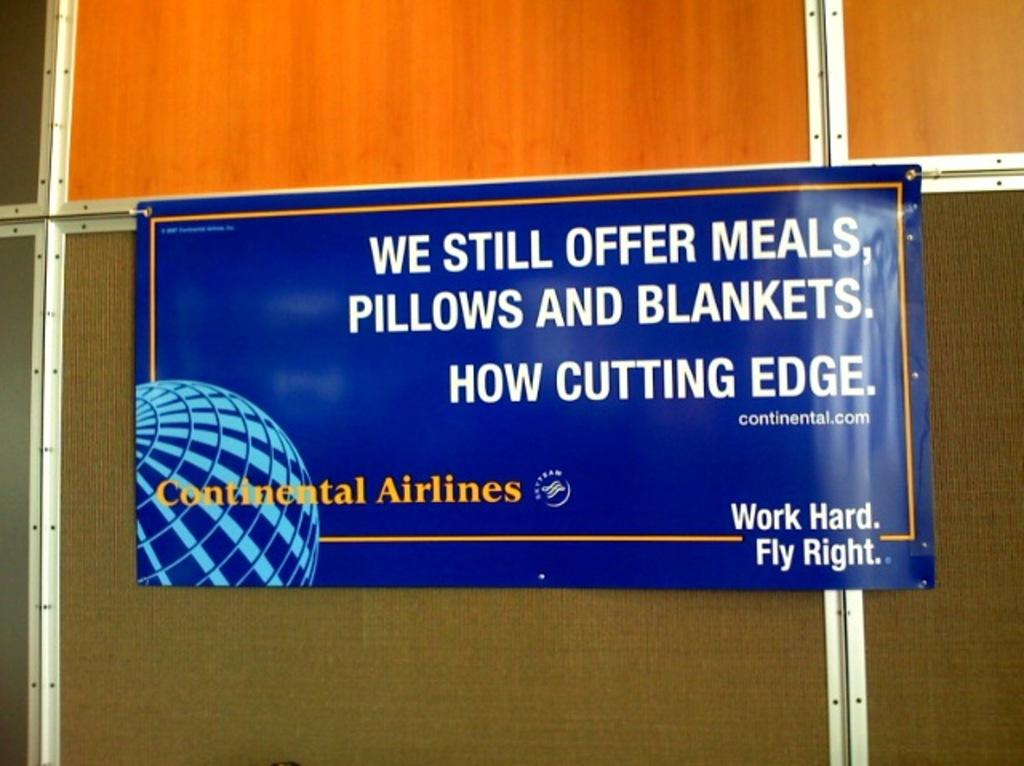<image>
Create a compact narrative representing the image presented. A sign on a wood board that says We still offer meals. 